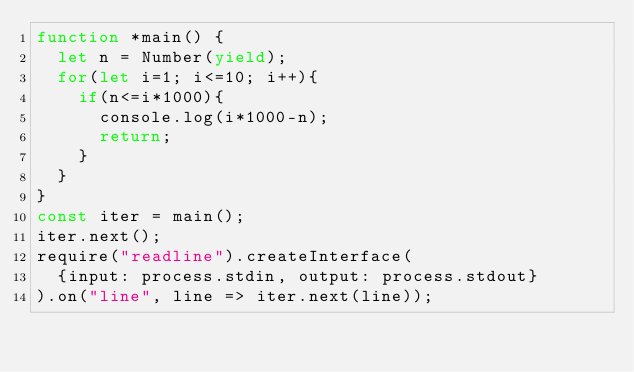<code> <loc_0><loc_0><loc_500><loc_500><_JavaScript_>function *main() {
  let n = Number(yield);
  for(let i=1; i<=10; i++){
    if(n<=i*1000){
      console.log(i*1000-n);
      return;
    }
  }
}
const iter = main();
iter.next();
require("readline").createInterface(
  {input: process.stdin, output: process.stdout}
).on("line", line => iter.next(line));</code> 